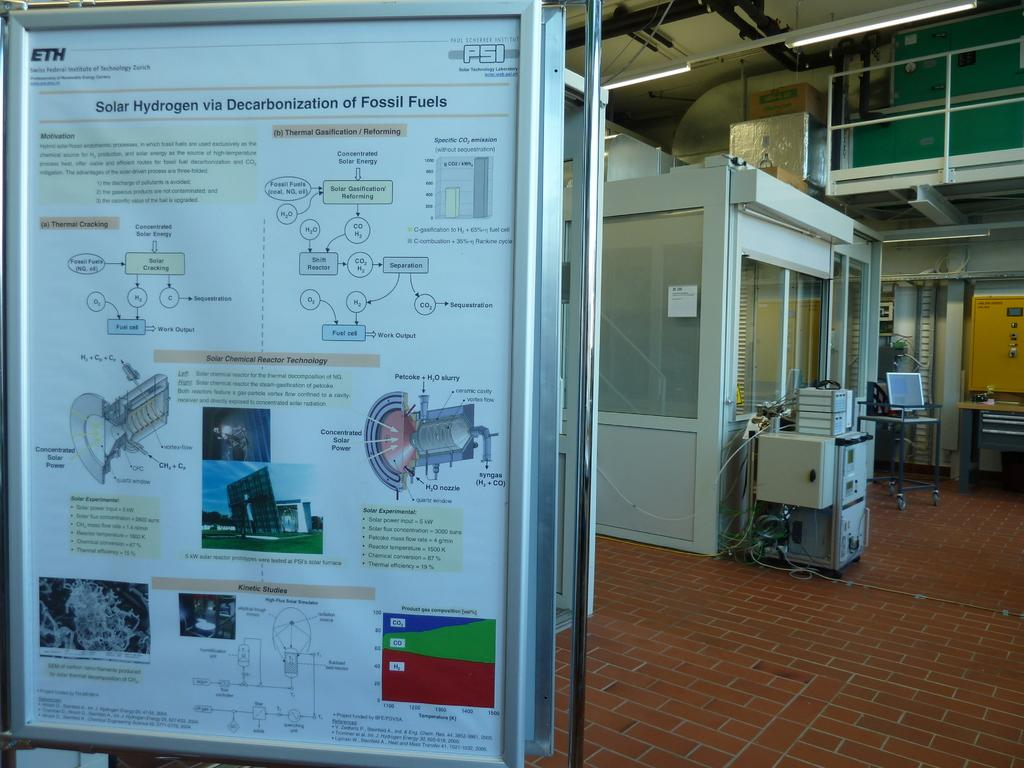<image>
Provide a brief description of the given image. A sign about solar hydrogen and fossil fuels stands on a brick floor. 